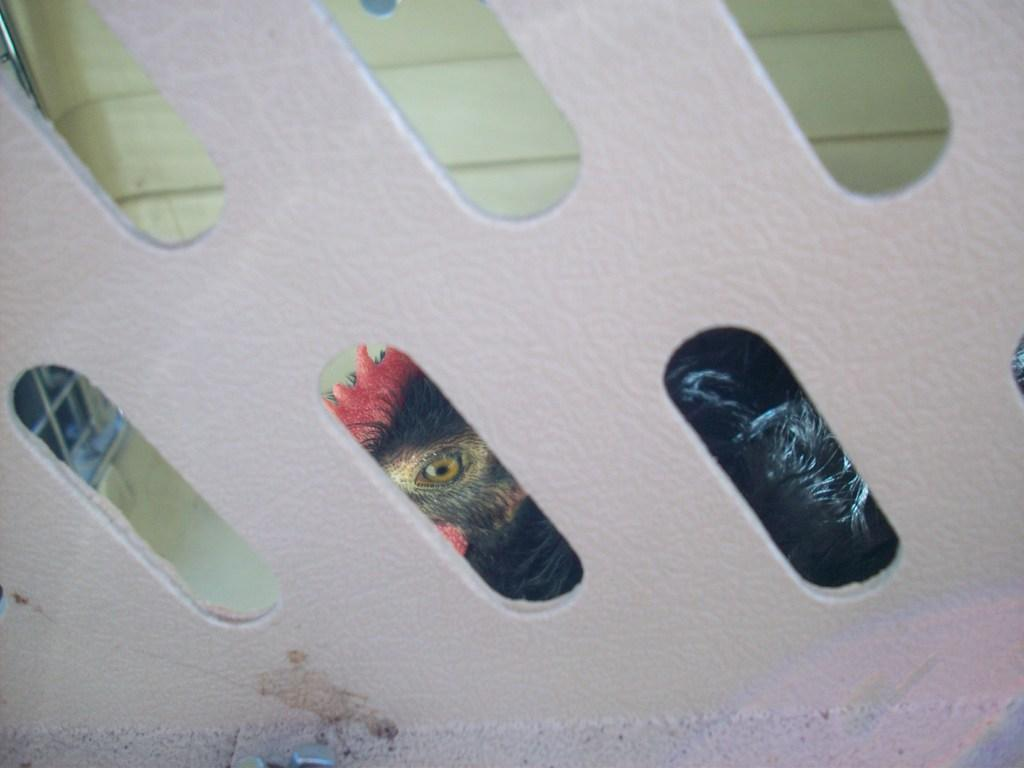What is the main subject of the image? The main subject of the image is a design wall. Can you describe the design wall in the image? Unfortunately, there is not enough information provided to describe the design wall in detail. What type of toothpaste is shown on the design wall in the image? There is no toothpaste present in the image; it only features a design wall. 